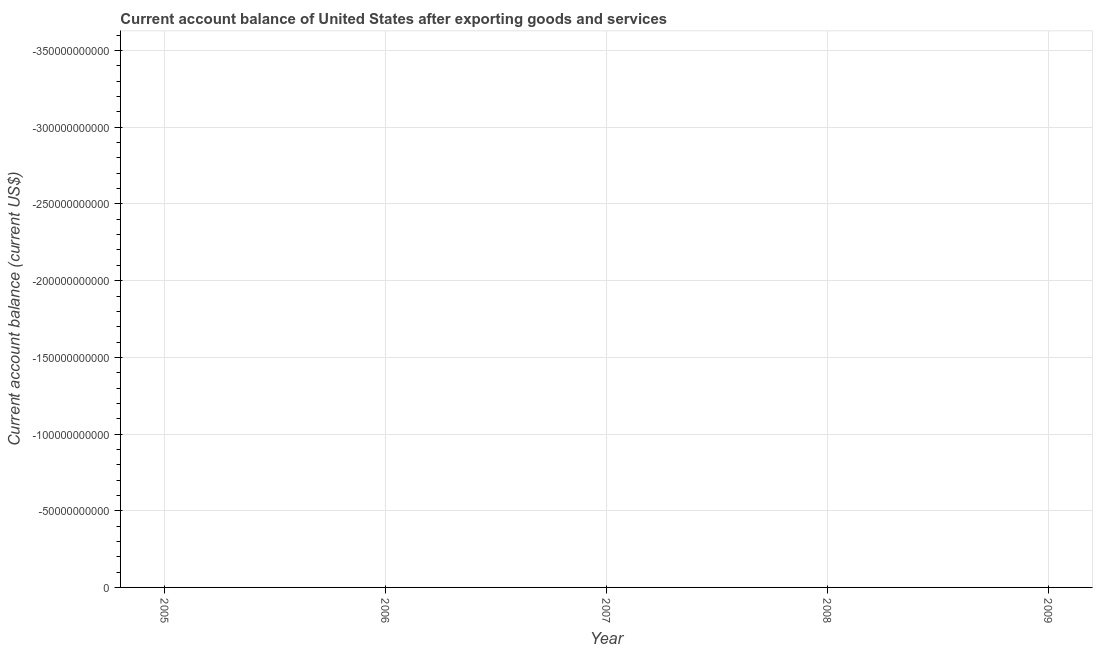Across all years, what is the minimum current account balance?
Make the answer very short. 0. What is the median current account balance?
Your answer should be compact. 0. In how many years, is the current account balance greater than -260000000000 US$?
Give a very brief answer. 0. In how many years, is the current account balance greater than the average current account balance taken over all years?
Your answer should be very brief. 0. Does the current account balance monotonically increase over the years?
Your answer should be very brief. No. What is the title of the graph?
Your response must be concise. Current account balance of United States after exporting goods and services. What is the label or title of the Y-axis?
Keep it short and to the point. Current account balance (current US$). What is the Current account balance (current US$) in 2006?
Provide a succinct answer. 0. What is the Current account balance (current US$) in 2009?
Provide a succinct answer. 0. 